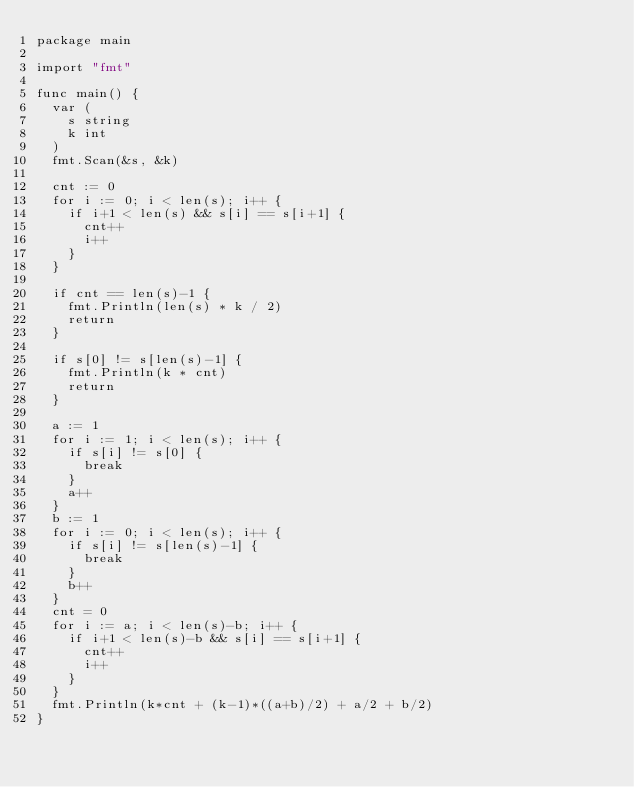<code> <loc_0><loc_0><loc_500><loc_500><_Go_>package main

import "fmt"

func main() {
	var (
		s string
		k int
	)
	fmt.Scan(&s, &k)

	cnt := 0
	for i := 0; i < len(s); i++ {
		if i+1 < len(s) && s[i] == s[i+1] {
			cnt++
			i++
		}
	}

	if cnt == len(s)-1 {
		fmt.Println(len(s) * k / 2)
		return
	}

	if s[0] != s[len(s)-1] {
		fmt.Println(k * cnt)
		return
	}

	a := 1
	for i := 1; i < len(s); i++ {
		if s[i] != s[0] {
			break
		}
		a++
	}
	b := 1
	for i := 0; i < len(s); i++ {
		if s[i] != s[len(s)-1] {
			break
		}
		b++
	}
	cnt = 0
	for i := a; i < len(s)-b; i++ {
		if i+1 < len(s)-b && s[i] == s[i+1] {
			cnt++
			i++
		}
	}
	fmt.Println(k*cnt + (k-1)*((a+b)/2) + a/2 + b/2)
}
</code> 